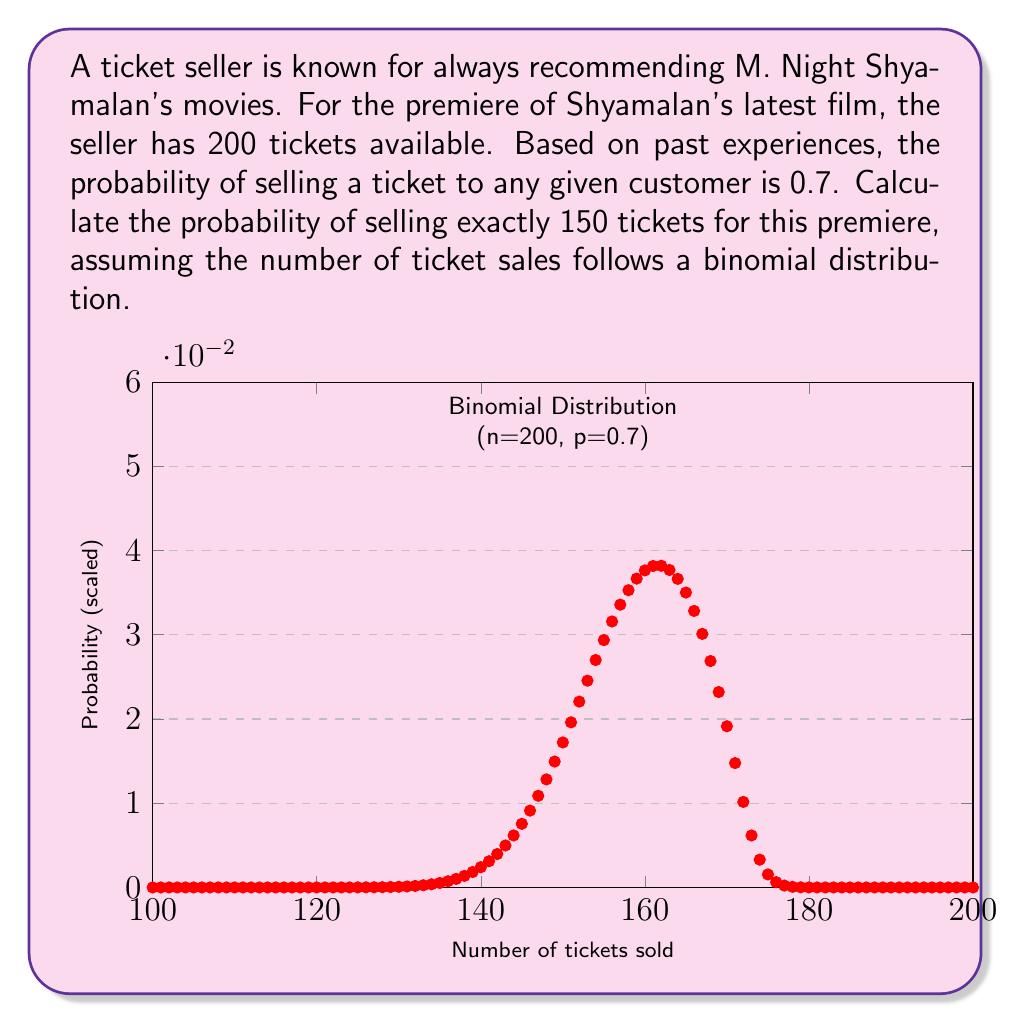Show me your answer to this math problem. To solve this problem, we'll use the binomial probability formula:

$$P(X = k) = \binom{n}{k} p^k (1-p)^{n-k}$$

Where:
- $n$ is the number of trials (total tickets available)
- $k$ is the number of successes (tickets we want to sell)
- $p$ is the probability of success on each trial (probability of selling a ticket to a customer)

Given:
- $n = 200$ (total tickets available)
- $k = 150$ (number of tickets we want to sell)
- $p = 0.7$ (probability of selling a ticket to a customer)

Step 1: Calculate the binomial coefficient $\binom{n}{k}$
$$\binom{200}{150} = \frac{200!}{150!(200-150)!} = \frac{200!}{150!50!}$$

Step 2: Substitute values into the binomial probability formula
$$P(X = 150) = \binom{200}{150} (0.7)^{150} (1-0.7)^{200-150}$$

Step 3: Simplify
$$P(X = 150) = \binom{200}{150} (0.7)^{150} (0.3)^{50}$$

Step 4: Calculate the result
Using a calculator or computer (due to the large numbers involved):
$$P(X = 150) \approx 0.0399$$

Therefore, the probability of selling exactly 150 tickets for the Shyamalan movie premiere is approximately 0.0399 or 3.99%.
Answer: $0.0399$ or $3.99\%$ 